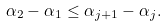<formula> <loc_0><loc_0><loc_500><loc_500>\alpha _ { 2 } - \alpha _ { 1 } \leq \alpha _ { j + 1 } - \alpha _ { j } .</formula> 